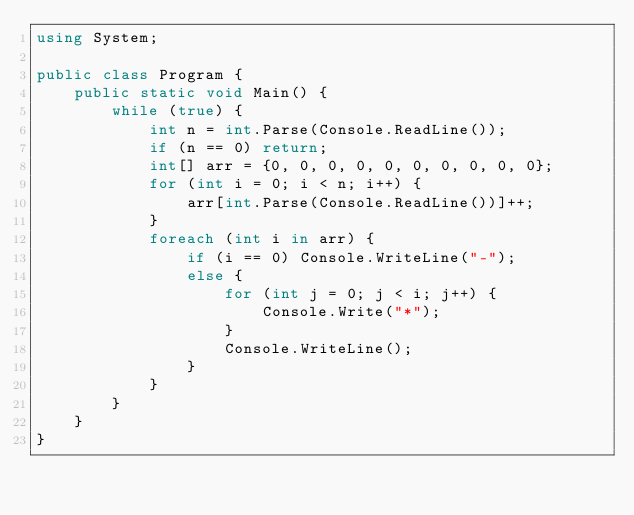Convert code to text. <code><loc_0><loc_0><loc_500><loc_500><_C#_>using System;

public class Program {
    public static void Main() {
        while (true) {
            int n = int.Parse(Console.ReadLine());
            if (n == 0) return;
            int[] arr = {0, 0, 0, 0, 0, 0, 0, 0, 0, 0};
            for (int i = 0; i < n; i++) {
                arr[int.Parse(Console.ReadLine())]++;
            }
            foreach (int i in arr) {
                if (i == 0) Console.WriteLine("-");
                else {
                    for (int j = 0; j < i; j++) {
                        Console.Write("*");
                    }
                    Console.WriteLine();
                }
            }
        }
    }
}</code> 